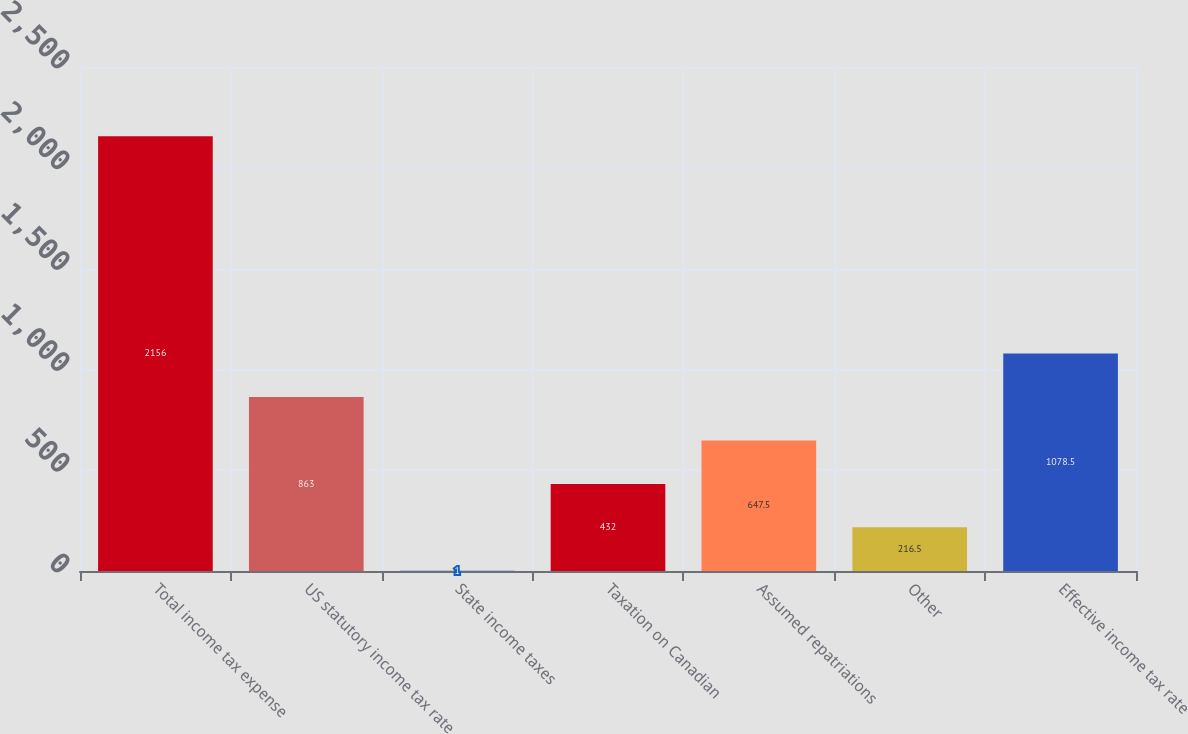Convert chart. <chart><loc_0><loc_0><loc_500><loc_500><bar_chart><fcel>Total income tax expense<fcel>US statutory income tax rate<fcel>State income taxes<fcel>Taxation on Canadian<fcel>Assumed repatriations<fcel>Other<fcel>Effective income tax rate<nl><fcel>2156<fcel>863<fcel>1<fcel>432<fcel>647.5<fcel>216.5<fcel>1078.5<nl></chart> 